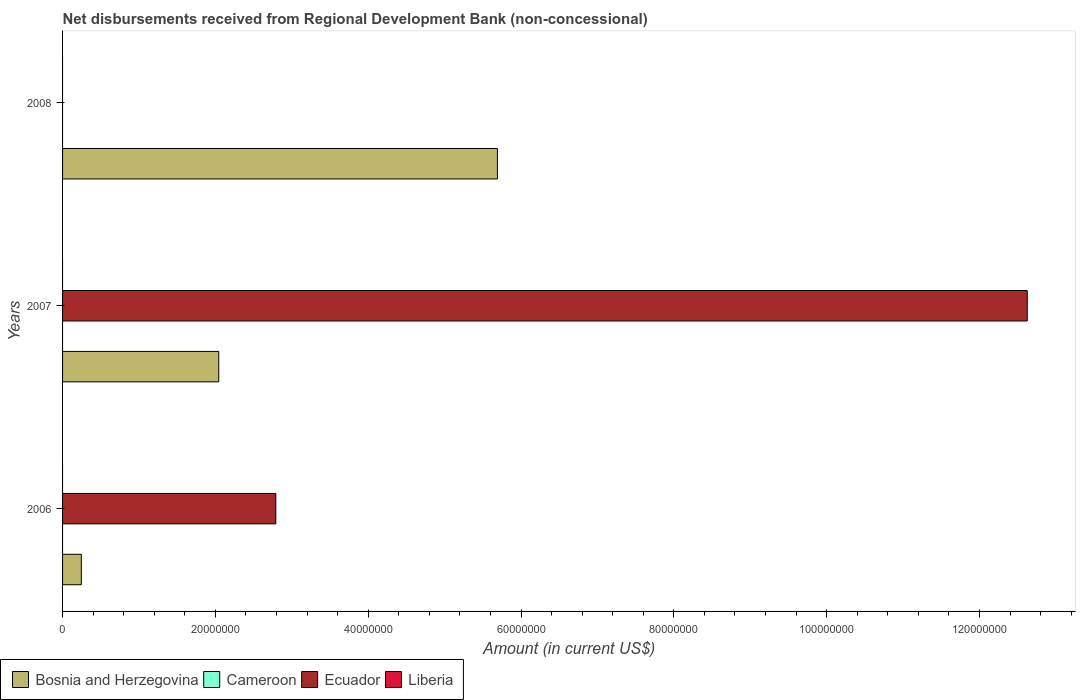Are the number of bars on each tick of the Y-axis equal?
Give a very brief answer. No. What is the amount of disbursements received from Regional Development Bank in Bosnia and Herzegovina in 2008?
Offer a terse response. 5.69e+07. Across all years, what is the maximum amount of disbursements received from Regional Development Bank in Bosnia and Herzegovina?
Provide a succinct answer. 5.69e+07. Across all years, what is the minimum amount of disbursements received from Regional Development Bank in Ecuador?
Keep it short and to the point. 0. In which year was the amount of disbursements received from Regional Development Bank in Ecuador maximum?
Offer a very short reply. 2007. What is the total amount of disbursements received from Regional Development Bank in Bosnia and Herzegovina in the graph?
Your response must be concise. 7.98e+07. What is the difference between the amount of disbursements received from Regional Development Bank in Bosnia and Herzegovina in 2006 and that in 2007?
Make the answer very short. -1.80e+07. What is the difference between the amount of disbursements received from Regional Development Bank in Cameroon in 2006 and the amount of disbursements received from Regional Development Bank in Bosnia and Herzegovina in 2007?
Make the answer very short. -2.04e+07. In the year 2006, what is the difference between the amount of disbursements received from Regional Development Bank in Bosnia and Herzegovina and amount of disbursements received from Regional Development Bank in Ecuador?
Provide a short and direct response. -2.55e+07. What is the ratio of the amount of disbursements received from Regional Development Bank in Ecuador in 2006 to that in 2007?
Offer a very short reply. 0.22. Is the difference between the amount of disbursements received from Regional Development Bank in Bosnia and Herzegovina in 2006 and 2007 greater than the difference between the amount of disbursements received from Regional Development Bank in Ecuador in 2006 and 2007?
Your response must be concise. Yes. What is the difference between the highest and the second highest amount of disbursements received from Regional Development Bank in Bosnia and Herzegovina?
Provide a short and direct response. 3.65e+07. What is the difference between the highest and the lowest amount of disbursements received from Regional Development Bank in Bosnia and Herzegovina?
Your answer should be very brief. 5.45e+07. In how many years, is the amount of disbursements received from Regional Development Bank in Liberia greater than the average amount of disbursements received from Regional Development Bank in Liberia taken over all years?
Your response must be concise. 0. Is it the case that in every year, the sum of the amount of disbursements received from Regional Development Bank in Ecuador and amount of disbursements received from Regional Development Bank in Liberia is greater than the amount of disbursements received from Regional Development Bank in Cameroon?
Make the answer very short. No. How many bars are there?
Provide a succinct answer. 5. How many years are there in the graph?
Ensure brevity in your answer.  3. Are the values on the major ticks of X-axis written in scientific E-notation?
Offer a very short reply. No. Does the graph contain any zero values?
Provide a succinct answer. Yes. Does the graph contain grids?
Provide a short and direct response. No. What is the title of the graph?
Provide a succinct answer. Net disbursements received from Regional Development Bank (non-concessional). Does "Sri Lanka" appear as one of the legend labels in the graph?
Your answer should be compact. No. What is the label or title of the X-axis?
Offer a very short reply. Amount (in current US$). What is the label or title of the Y-axis?
Keep it short and to the point. Years. What is the Amount (in current US$) of Bosnia and Herzegovina in 2006?
Give a very brief answer. 2.46e+06. What is the Amount (in current US$) in Ecuador in 2006?
Your answer should be very brief. 2.79e+07. What is the Amount (in current US$) in Bosnia and Herzegovina in 2007?
Give a very brief answer. 2.04e+07. What is the Amount (in current US$) in Ecuador in 2007?
Your answer should be compact. 1.26e+08. What is the Amount (in current US$) in Liberia in 2007?
Your answer should be very brief. 0. What is the Amount (in current US$) in Bosnia and Herzegovina in 2008?
Ensure brevity in your answer.  5.69e+07. What is the Amount (in current US$) of Ecuador in 2008?
Your answer should be very brief. 0. Across all years, what is the maximum Amount (in current US$) in Bosnia and Herzegovina?
Offer a very short reply. 5.69e+07. Across all years, what is the maximum Amount (in current US$) in Ecuador?
Provide a succinct answer. 1.26e+08. Across all years, what is the minimum Amount (in current US$) in Bosnia and Herzegovina?
Make the answer very short. 2.46e+06. Across all years, what is the minimum Amount (in current US$) in Ecuador?
Offer a terse response. 0. What is the total Amount (in current US$) of Bosnia and Herzegovina in the graph?
Offer a terse response. 7.98e+07. What is the total Amount (in current US$) in Cameroon in the graph?
Provide a succinct answer. 0. What is the total Amount (in current US$) of Ecuador in the graph?
Offer a very short reply. 1.54e+08. What is the difference between the Amount (in current US$) of Bosnia and Herzegovina in 2006 and that in 2007?
Ensure brevity in your answer.  -1.80e+07. What is the difference between the Amount (in current US$) of Ecuador in 2006 and that in 2007?
Make the answer very short. -9.83e+07. What is the difference between the Amount (in current US$) of Bosnia and Herzegovina in 2006 and that in 2008?
Provide a short and direct response. -5.45e+07. What is the difference between the Amount (in current US$) of Bosnia and Herzegovina in 2007 and that in 2008?
Your answer should be compact. -3.65e+07. What is the difference between the Amount (in current US$) of Bosnia and Herzegovina in 2006 and the Amount (in current US$) of Ecuador in 2007?
Ensure brevity in your answer.  -1.24e+08. What is the average Amount (in current US$) in Bosnia and Herzegovina per year?
Make the answer very short. 2.66e+07. What is the average Amount (in current US$) in Ecuador per year?
Offer a very short reply. 5.14e+07. In the year 2006, what is the difference between the Amount (in current US$) of Bosnia and Herzegovina and Amount (in current US$) of Ecuador?
Offer a terse response. -2.55e+07. In the year 2007, what is the difference between the Amount (in current US$) of Bosnia and Herzegovina and Amount (in current US$) of Ecuador?
Your answer should be very brief. -1.06e+08. What is the ratio of the Amount (in current US$) of Bosnia and Herzegovina in 2006 to that in 2007?
Give a very brief answer. 0.12. What is the ratio of the Amount (in current US$) of Ecuador in 2006 to that in 2007?
Your answer should be very brief. 0.22. What is the ratio of the Amount (in current US$) of Bosnia and Herzegovina in 2006 to that in 2008?
Give a very brief answer. 0.04. What is the ratio of the Amount (in current US$) in Bosnia and Herzegovina in 2007 to that in 2008?
Make the answer very short. 0.36. What is the difference between the highest and the second highest Amount (in current US$) of Bosnia and Herzegovina?
Your response must be concise. 3.65e+07. What is the difference between the highest and the lowest Amount (in current US$) in Bosnia and Herzegovina?
Provide a short and direct response. 5.45e+07. What is the difference between the highest and the lowest Amount (in current US$) of Ecuador?
Your answer should be compact. 1.26e+08. 